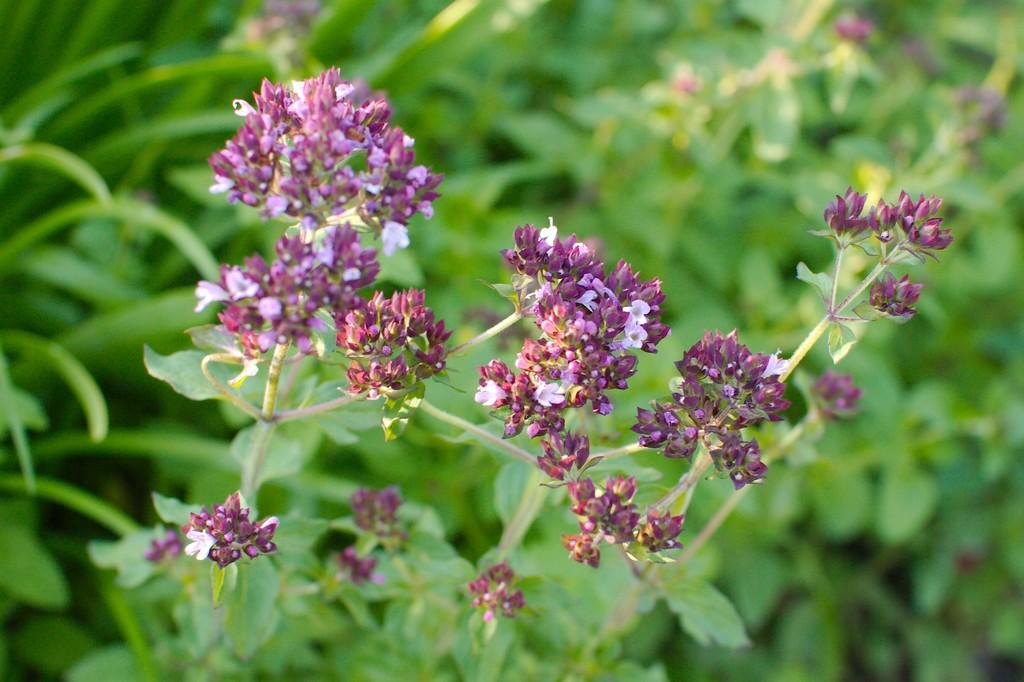What type of plant is depicted in the image? There are flowers in the image. What color are the flowers? The flowers are purple in color. What parts of the flower can be seen in the image? The stem and leaves of the flower are visible. How would you describe the background of the image? The background of the image is blurred. What time of day is it in the image, and who is giving a kiss? The time of day is not mentioned in the image, and there is no indication of anyone giving a kiss. 